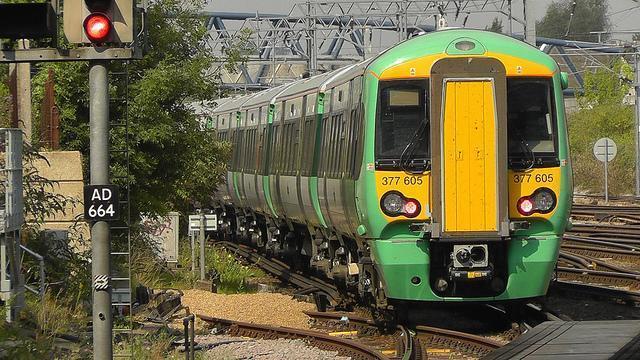How many trains can be seen?
Give a very brief answer. 1. How many baby bears are in the picture?
Give a very brief answer. 0. 